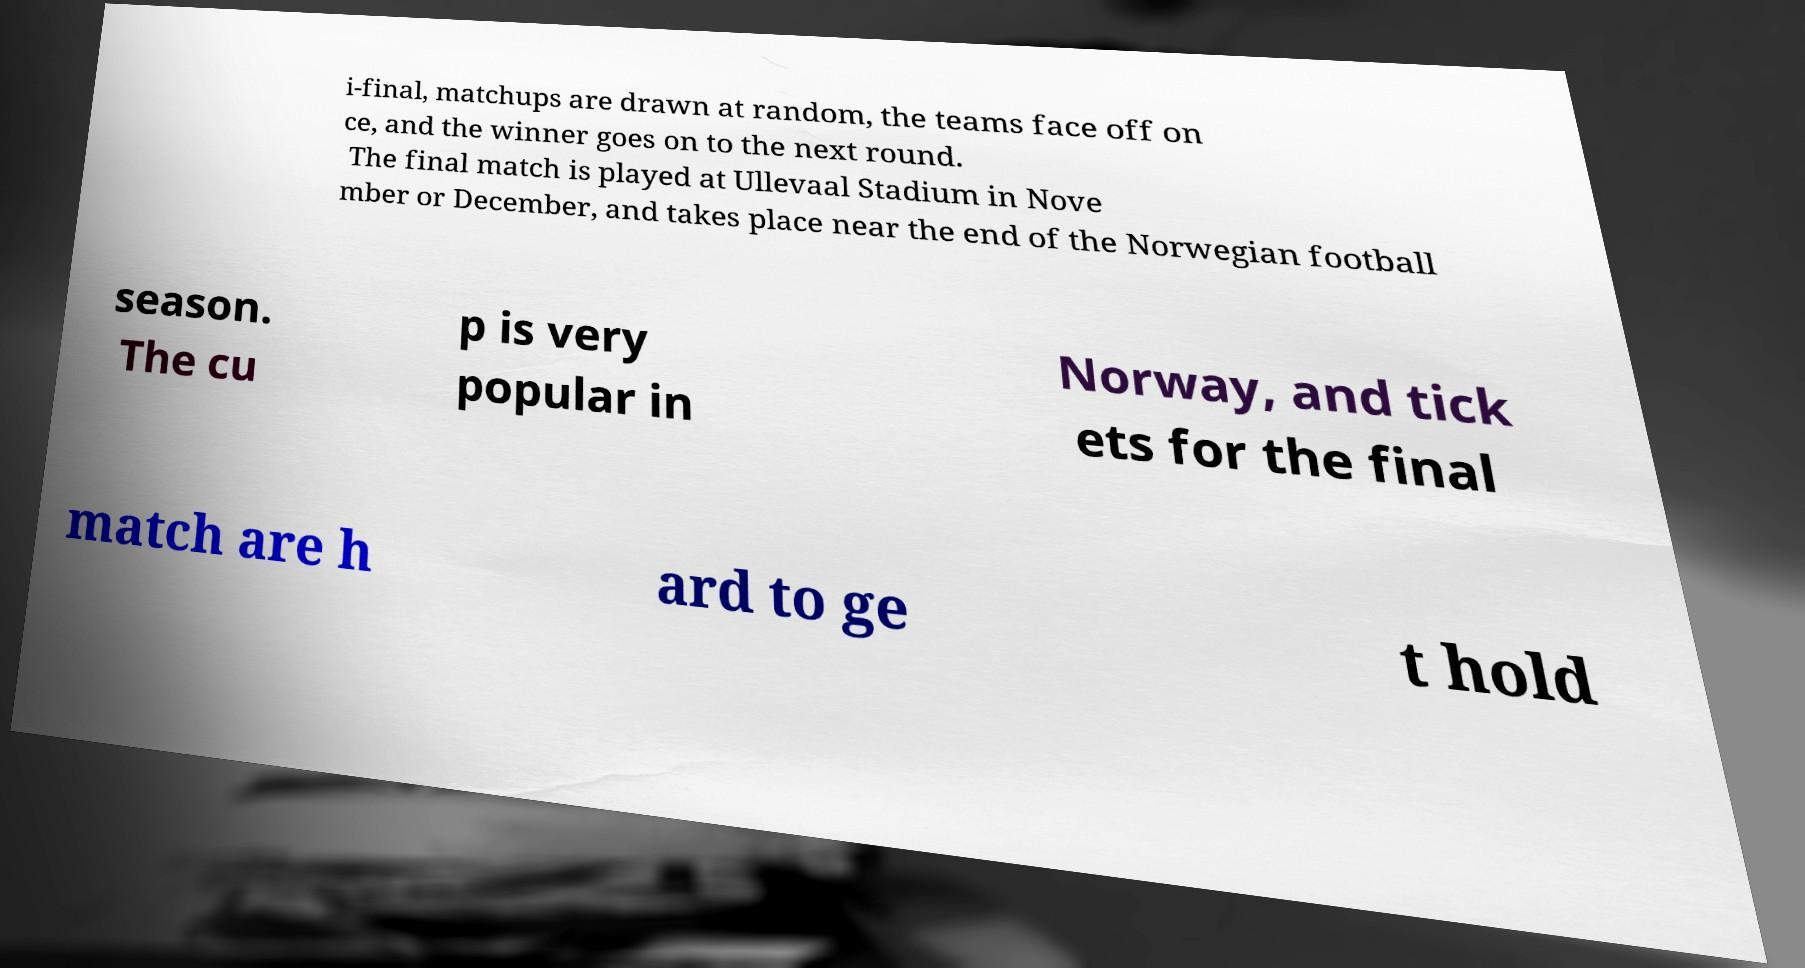Can you read and provide the text displayed in the image?This photo seems to have some interesting text. Can you extract and type it out for me? i-final, matchups are drawn at random, the teams face off on ce, and the winner goes on to the next round. The final match is played at Ullevaal Stadium in Nove mber or December, and takes place near the end of the Norwegian football season. The cu p is very popular in Norway, and tick ets for the final match are h ard to ge t hold 